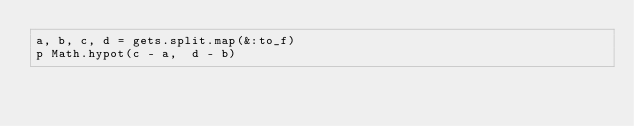<code> <loc_0><loc_0><loc_500><loc_500><_Ruby_>a, b, c, d = gets.split.map(&:to_f)
p Math.hypot(c - a,  d - b)</code> 